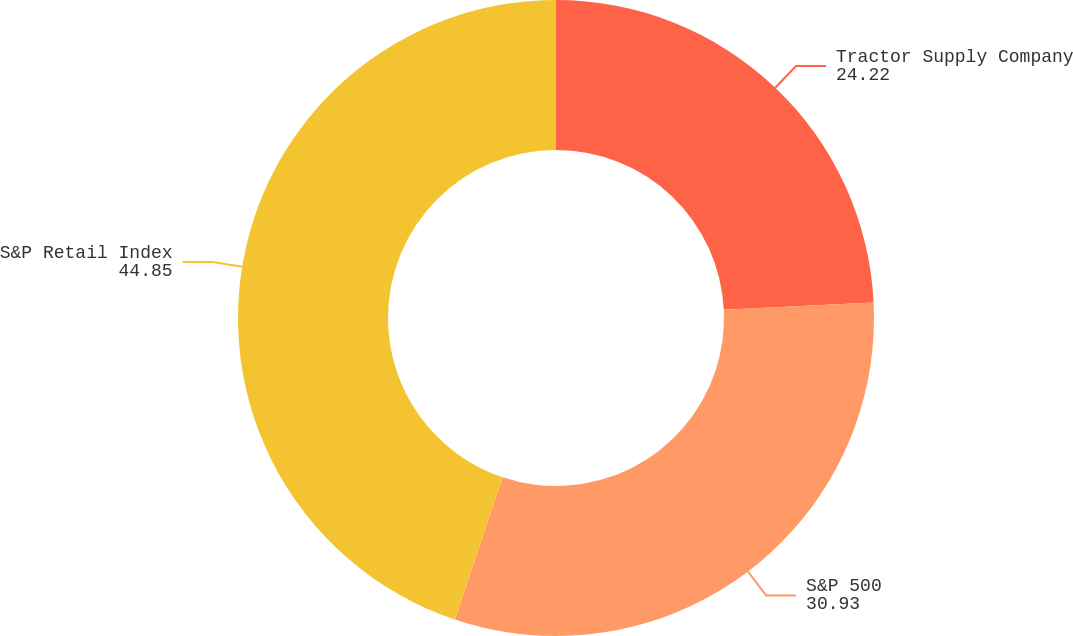<chart> <loc_0><loc_0><loc_500><loc_500><pie_chart><fcel>Tractor Supply Company<fcel>S&P 500<fcel>S&P Retail Index<nl><fcel>24.22%<fcel>30.93%<fcel>44.85%<nl></chart> 